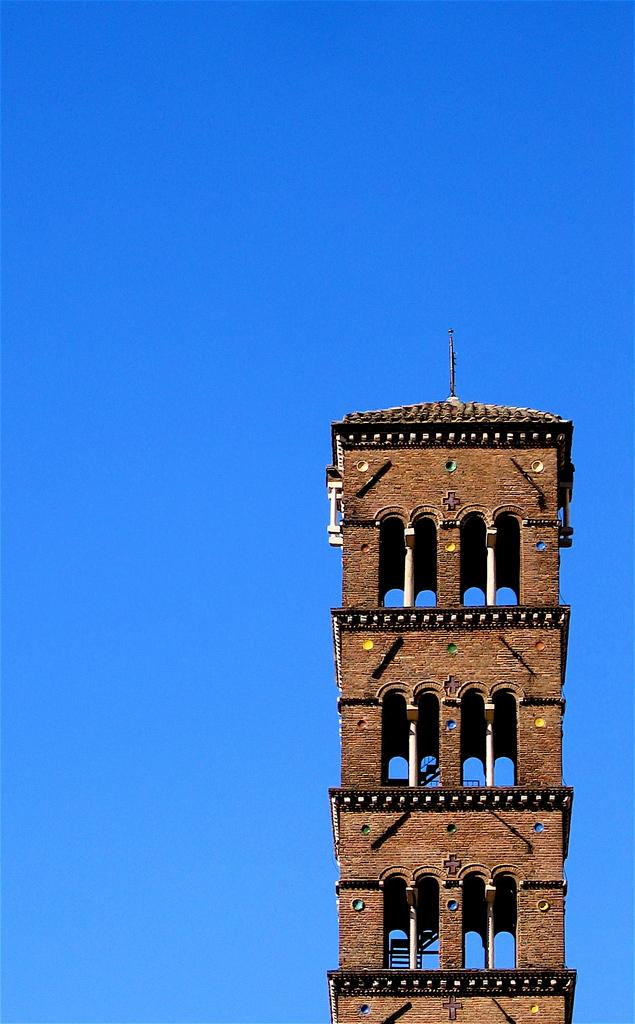What is the main structure in the center of the image? There is a tower in the center of the image. What can be seen in the background of the image? The sky is visible in the image. What architectural features are present in the image? There are pillars in the image. What other object can be seen in the image? There is a pole in the image. Can you describe any other objects in the image? There are a few other objects in the image. Where is the market located in the image? There is no market present in the image. What type of board is being used by the people in the image? There are no people or boards present in the image. 